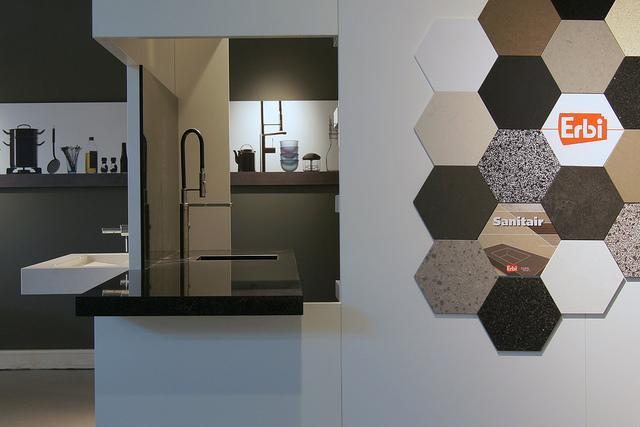How many sinks are in the picture?
Give a very brief answer. 1. How many people is this man playing against?
Give a very brief answer. 0. 